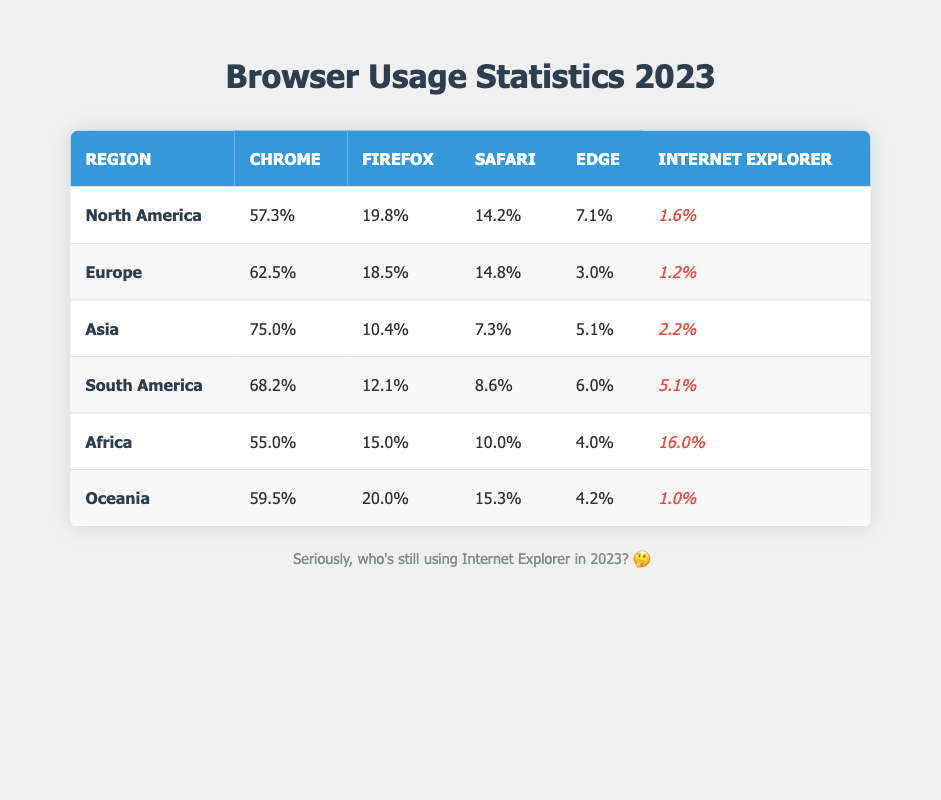What percentage of users in North America use Chrome? The table indicates that Chrome usage in North America is 57.3%.
Answer: 57.3% Which region has the highest percentage of Internet Explorer usage? Looking at the table, Africa has the highest percentage of Internet Explorer usage at 16.0%.
Answer: Africa What is the total percentage of usage for Chrome and Safari in Asia? In Asia, Chrome usage is 75.0% and Safari usage is 7.3%. Adding these values gives 75.0 + 7.3 = 82.3%.
Answer: 82.3% Is Firefox more popular than Edge in Europe? The table shows Firefox at 18.5% and Edge at 3.0%. Since 18.5% is greater than 3.0%, the answer is yes.
Answer: Yes What is the difference in percentage between Safari usage in South America and in Oceania? In South America, Safari usage is 8.6%, and in Oceania, it is 15.3%. The difference is 15.3 - 8.6 = 6.7%.
Answer: 6.7% 